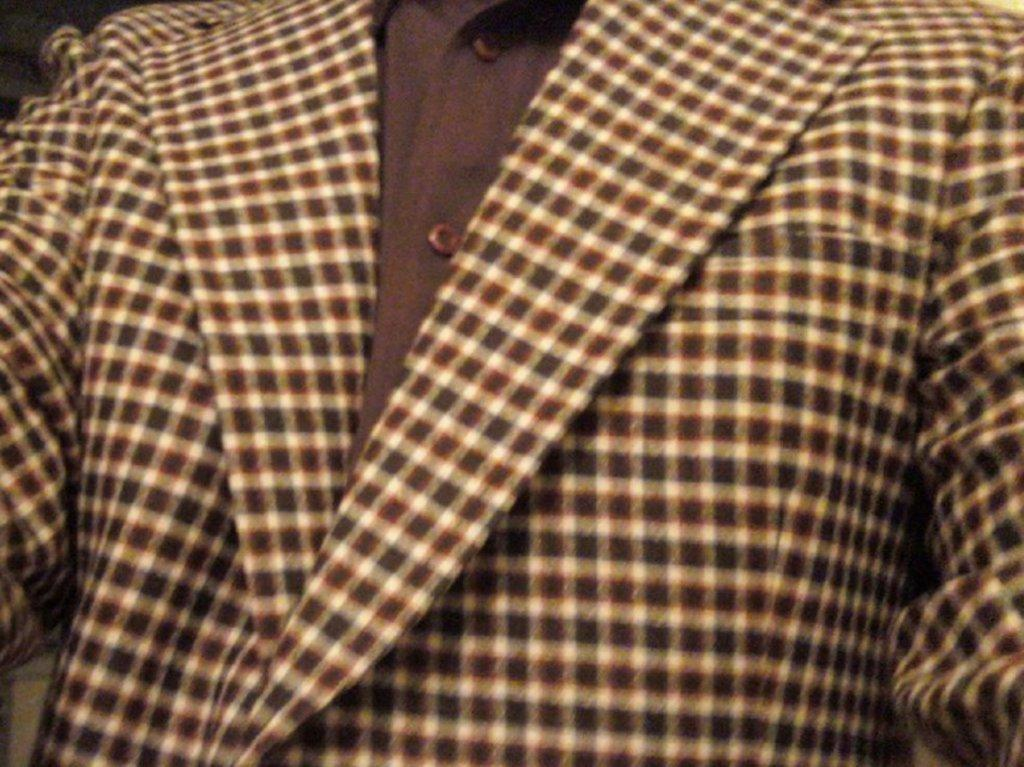What type of clothing item is in the image? There is a suit in the image. What type of glove is being used to cook in the image? There is no glove or cooking activity present in the image; it only features a suit. 